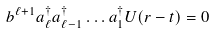Convert formula to latex. <formula><loc_0><loc_0><loc_500><loc_500>b ^ { \ell + 1 } a _ { \ell } ^ { \dagger } a _ { \ell - 1 } ^ { \dagger } \dots a _ { 1 } ^ { \dagger } U ( r - t ) = 0</formula> 